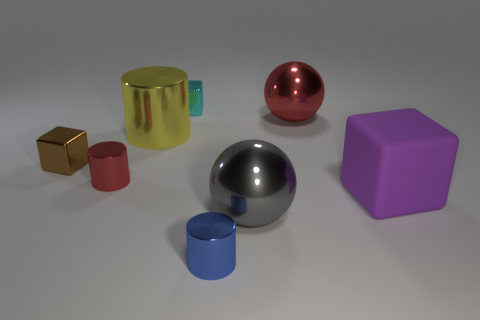Add 1 small brown metal things. How many objects exist? 9 Subtract all cubes. How many objects are left? 5 Subtract 0 blue spheres. How many objects are left? 8 Subtract all big red balls. Subtract all large gray shiny things. How many objects are left? 6 Add 8 tiny brown metal blocks. How many tiny brown metal blocks are left? 9 Add 3 big blue cubes. How many big blue cubes exist? 3 